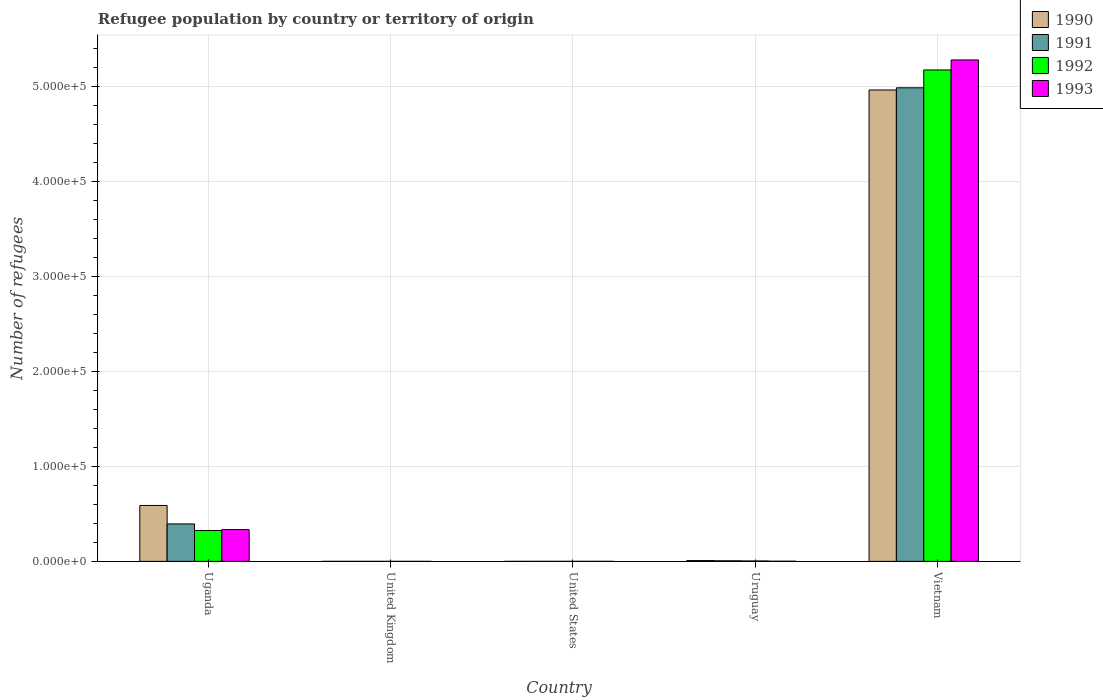How many groups of bars are there?
Your response must be concise. 5. Are the number of bars on each tick of the X-axis equal?
Your answer should be compact. Yes. How many bars are there on the 3rd tick from the left?
Provide a succinct answer. 4. What is the label of the 2nd group of bars from the left?
Offer a terse response. United Kingdom. In how many cases, is the number of bars for a given country not equal to the number of legend labels?
Your response must be concise. 0. Across all countries, what is the maximum number of refugees in 1991?
Make the answer very short. 4.98e+05. In which country was the number of refugees in 1991 maximum?
Your answer should be very brief. Vietnam. In which country was the number of refugees in 1991 minimum?
Your answer should be very brief. United Kingdom. What is the total number of refugees in 1990 in the graph?
Your answer should be compact. 5.56e+05. What is the average number of refugees in 1991 per country?
Make the answer very short. 1.08e+05. What is the difference between the number of refugees of/in 1993 and number of refugees of/in 1991 in Vietnam?
Your answer should be very brief. 2.93e+04. In how many countries, is the number of refugees in 1991 greater than 440000?
Provide a short and direct response. 1. What is the ratio of the number of refugees in 1990 in United States to that in Vietnam?
Provide a short and direct response. 2.0160111606377854e-6. Is the difference between the number of refugees in 1993 in United Kingdom and United States greater than the difference between the number of refugees in 1991 in United Kingdom and United States?
Provide a short and direct response. No. What is the difference between the highest and the second highest number of refugees in 1991?
Keep it short and to the point. -3.88e+04. What is the difference between the highest and the lowest number of refugees in 1992?
Your answer should be very brief. 5.17e+05. In how many countries, is the number of refugees in 1992 greater than the average number of refugees in 1992 taken over all countries?
Offer a very short reply. 1. Is it the case that in every country, the sum of the number of refugees in 1990 and number of refugees in 1992 is greater than the sum of number of refugees in 1993 and number of refugees in 1991?
Provide a short and direct response. No. What does the 1st bar from the left in Uruguay represents?
Provide a short and direct response. 1990. How many bars are there?
Provide a short and direct response. 20. Are all the bars in the graph horizontal?
Give a very brief answer. No. Are the values on the major ticks of Y-axis written in scientific E-notation?
Your answer should be very brief. Yes. Does the graph contain any zero values?
Offer a terse response. No. Does the graph contain grids?
Make the answer very short. Yes. How many legend labels are there?
Your answer should be compact. 4. How are the legend labels stacked?
Offer a very short reply. Vertical. What is the title of the graph?
Your answer should be compact. Refugee population by country or territory of origin. Does "1990" appear as one of the legend labels in the graph?
Your answer should be very brief. Yes. What is the label or title of the X-axis?
Your answer should be compact. Country. What is the label or title of the Y-axis?
Make the answer very short. Number of refugees. What is the Number of refugees of 1990 in Uganda?
Keep it short and to the point. 5.88e+04. What is the Number of refugees of 1991 in Uganda?
Offer a terse response. 3.94e+04. What is the Number of refugees of 1992 in Uganda?
Offer a very short reply. 3.25e+04. What is the Number of refugees in 1993 in Uganda?
Offer a terse response. 3.34e+04. What is the Number of refugees of 1990 in United States?
Make the answer very short. 1. What is the Number of refugees in 1991 in United States?
Provide a succinct answer. 8. What is the Number of refugees of 1992 in United States?
Offer a very short reply. 10. What is the Number of refugees of 1990 in Uruguay?
Offer a terse response. 842. What is the Number of refugees in 1991 in Uruguay?
Give a very brief answer. 601. What is the Number of refugees of 1992 in Uruguay?
Provide a succinct answer. 429. What is the Number of refugees of 1993 in Uruguay?
Provide a short and direct response. 162. What is the Number of refugees of 1990 in Vietnam?
Offer a terse response. 4.96e+05. What is the Number of refugees in 1991 in Vietnam?
Offer a terse response. 4.98e+05. What is the Number of refugees in 1992 in Vietnam?
Offer a very short reply. 5.17e+05. What is the Number of refugees of 1993 in Vietnam?
Your answer should be compact. 5.28e+05. Across all countries, what is the maximum Number of refugees in 1990?
Give a very brief answer. 4.96e+05. Across all countries, what is the maximum Number of refugees in 1991?
Your answer should be compact. 4.98e+05. Across all countries, what is the maximum Number of refugees of 1992?
Offer a very short reply. 5.17e+05. Across all countries, what is the maximum Number of refugees of 1993?
Your answer should be compact. 5.28e+05. Across all countries, what is the minimum Number of refugees of 1990?
Your response must be concise. 1. Across all countries, what is the minimum Number of refugees of 1991?
Keep it short and to the point. 1. What is the total Number of refugees of 1990 in the graph?
Your answer should be very brief. 5.56e+05. What is the total Number of refugees of 1991 in the graph?
Your response must be concise. 5.38e+05. What is the total Number of refugees of 1992 in the graph?
Your answer should be compact. 5.50e+05. What is the total Number of refugees of 1993 in the graph?
Offer a terse response. 5.61e+05. What is the difference between the Number of refugees of 1990 in Uganda and that in United Kingdom?
Offer a very short reply. 5.88e+04. What is the difference between the Number of refugees of 1991 in Uganda and that in United Kingdom?
Provide a succinct answer. 3.94e+04. What is the difference between the Number of refugees of 1992 in Uganda and that in United Kingdom?
Your response must be concise. 3.25e+04. What is the difference between the Number of refugees of 1993 in Uganda and that in United Kingdom?
Offer a terse response. 3.34e+04. What is the difference between the Number of refugees in 1990 in Uganda and that in United States?
Keep it short and to the point. 5.88e+04. What is the difference between the Number of refugees of 1991 in Uganda and that in United States?
Provide a succinct answer. 3.94e+04. What is the difference between the Number of refugees in 1992 in Uganda and that in United States?
Make the answer very short. 3.24e+04. What is the difference between the Number of refugees in 1993 in Uganda and that in United States?
Your answer should be very brief. 3.34e+04. What is the difference between the Number of refugees of 1990 in Uganda and that in Uruguay?
Provide a short and direct response. 5.80e+04. What is the difference between the Number of refugees of 1991 in Uganda and that in Uruguay?
Offer a terse response. 3.88e+04. What is the difference between the Number of refugees of 1992 in Uganda and that in Uruguay?
Give a very brief answer. 3.20e+04. What is the difference between the Number of refugees of 1993 in Uganda and that in Uruguay?
Offer a very short reply. 3.33e+04. What is the difference between the Number of refugees of 1990 in Uganda and that in Vietnam?
Provide a succinct answer. -4.37e+05. What is the difference between the Number of refugees of 1991 in Uganda and that in Vietnam?
Ensure brevity in your answer.  -4.59e+05. What is the difference between the Number of refugees in 1992 in Uganda and that in Vietnam?
Offer a terse response. -4.85e+05. What is the difference between the Number of refugees of 1993 in Uganda and that in Vietnam?
Keep it short and to the point. -4.94e+05. What is the difference between the Number of refugees in 1990 in United Kingdom and that in United States?
Provide a succinct answer. 0. What is the difference between the Number of refugees in 1991 in United Kingdom and that in United States?
Your answer should be very brief. -7. What is the difference between the Number of refugees in 1992 in United Kingdom and that in United States?
Ensure brevity in your answer.  -9. What is the difference between the Number of refugees in 1990 in United Kingdom and that in Uruguay?
Give a very brief answer. -841. What is the difference between the Number of refugees in 1991 in United Kingdom and that in Uruguay?
Make the answer very short. -600. What is the difference between the Number of refugees of 1992 in United Kingdom and that in Uruguay?
Keep it short and to the point. -428. What is the difference between the Number of refugees in 1993 in United Kingdom and that in Uruguay?
Give a very brief answer. -160. What is the difference between the Number of refugees in 1990 in United Kingdom and that in Vietnam?
Offer a terse response. -4.96e+05. What is the difference between the Number of refugees in 1991 in United Kingdom and that in Vietnam?
Provide a short and direct response. -4.98e+05. What is the difference between the Number of refugees of 1992 in United Kingdom and that in Vietnam?
Provide a short and direct response. -5.17e+05. What is the difference between the Number of refugees in 1993 in United Kingdom and that in Vietnam?
Your answer should be very brief. -5.28e+05. What is the difference between the Number of refugees of 1990 in United States and that in Uruguay?
Your answer should be compact. -841. What is the difference between the Number of refugees of 1991 in United States and that in Uruguay?
Give a very brief answer. -593. What is the difference between the Number of refugees in 1992 in United States and that in Uruguay?
Keep it short and to the point. -419. What is the difference between the Number of refugees in 1993 in United States and that in Uruguay?
Keep it short and to the point. -150. What is the difference between the Number of refugees of 1990 in United States and that in Vietnam?
Provide a short and direct response. -4.96e+05. What is the difference between the Number of refugees in 1991 in United States and that in Vietnam?
Offer a very short reply. -4.98e+05. What is the difference between the Number of refugees of 1992 in United States and that in Vietnam?
Ensure brevity in your answer.  -5.17e+05. What is the difference between the Number of refugees in 1993 in United States and that in Vietnam?
Keep it short and to the point. -5.28e+05. What is the difference between the Number of refugees in 1990 in Uruguay and that in Vietnam?
Ensure brevity in your answer.  -4.95e+05. What is the difference between the Number of refugees of 1991 in Uruguay and that in Vietnam?
Give a very brief answer. -4.98e+05. What is the difference between the Number of refugees of 1992 in Uruguay and that in Vietnam?
Provide a succinct answer. -5.17e+05. What is the difference between the Number of refugees in 1993 in Uruguay and that in Vietnam?
Give a very brief answer. -5.27e+05. What is the difference between the Number of refugees in 1990 in Uganda and the Number of refugees in 1991 in United Kingdom?
Your response must be concise. 5.88e+04. What is the difference between the Number of refugees in 1990 in Uganda and the Number of refugees in 1992 in United Kingdom?
Give a very brief answer. 5.88e+04. What is the difference between the Number of refugees of 1990 in Uganda and the Number of refugees of 1993 in United Kingdom?
Offer a very short reply. 5.88e+04. What is the difference between the Number of refugees of 1991 in Uganda and the Number of refugees of 1992 in United Kingdom?
Keep it short and to the point. 3.94e+04. What is the difference between the Number of refugees in 1991 in Uganda and the Number of refugees in 1993 in United Kingdom?
Provide a short and direct response. 3.94e+04. What is the difference between the Number of refugees of 1992 in Uganda and the Number of refugees of 1993 in United Kingdom?
Provide a short and direct response. 3.25e+04. What is the difference between the Number of refugees of 1990 in Uganda and the Number of refugees of 1991 in United States?
Your answer should be compact. 5.88e+04. What is the difference between the Number of refugees in 1990 in Uganda and the Number of refugees in 1992 in United States?
Give a very brief answer. 5.88e+04. What is the difference between the Number of refugees in 1990 in Uganda and the Number of refugees in 1993 in United States?
Give a very brief answer. 5.88e+04. What is the difference between the Number of refugees of 1991 in Uganda and the Number of refugees of 1992 in United States?
Offer a terse response. 3.94e+04. What is the difference between the Number of refugees in 1991 in Uganda and the Number of refugees in 1993 in United States?
Provide a short and direct response. 3.94e+04. What is the difference between the Number of refugees of 1992 in Uganda and the Number of refugees of 1993 in United States?
Make the answer very short. 3.24e+04. What is the difference between the Number of refugees of 1990 in Uganda and the Number of refugees of 1991 in Uruguay?
Provide a short and direct response. 5.82e+04. What is the difference between the Number of refugees of 1990 in Uganda and the Number of refugees of 1992 in Uruguay?
Give a very brief answer. 5.84e+04. What is the difference between the Number of refugees in 1990 in Uganda and the Number of refugees in 1993 in Uruguay?
Your answer should be compact. 5.87e+04. What is the difference between the Number of refugees in 1991 in Uganda and the Number of refugees in 1992 in Uruguay?
Offer a terse response. 3.90e+04. What is the difference between the Number of refugees of 1991 in Uganda and the Number of refugees of 1993 in Uruguay?
Offer a terse response. 3.92e+04. What is the difference between the Number of refugees in 1992 in Uganda and the Number of refugees in 1993 in Uruguay?
Make the answer very short. 3.23e+04. What is the difference between the Number of refugees of 1990 in Uganda and the Number of refugees of 1991 in Vietnam?
Ensure brevity in your answer.  -4.40e+05. What is the difference between the Number of refugees of 1990 in Uganda and the Number of refugees of 1992 in Vietnam?
Ensure brevity in your answer.  -4.58e+05. What is the difference between the Number of refugees in 1990 in Uganda and the Number of refugees in 1993 in Vietnam?
Keep it short and to the point. -4.69e+05. What is the difference between the Number of refugees of 1991 in Uganda and the Number of refugees of 1992 in Vietnam?
Your answer should be compact. -4.78e+05. What is the difference between the Number of refugees of 1991 in Uganda and the Number of refugees of 1993 in Vietnam?
Keep it short and to the point. -4.88e+05. What is the difference between the Number of refugees of 1992 in Uganda and the Number of refugees of 1993 in Vietnam?
Provide a succinct answer. -4.95e+05. What is the difference between the Number of refugees of 1990 in United Kingdom and the Number of refugees of 1992 in United States?
Your answer should be compact. -9. What is the difference between the Number of refugees in 1990 in United Kingdom and the Number of refugees in 1993 in United States?
Your answer should be compact. -11. What is the difference between the Number of refugees of 1991 in United Kingdom and the Number of refugees of 1993 in United States?
Keep it short and to the point. -11. What is the difference between the Number of refugees in 1990 in United Kingdom and the Number of refugees in 1991 in Uruguay?
Offer a terse response. -600. What is the difference between the Number of refugees in 1990 in United Kingdom and the Number of refugees in 1992 in Uruguay?
Provide a short and direct response. -428. What is the difference between the Number of refugees of 1990 in United Kingdom and the Number of refugees of 1993 in Uruguay?
Give a very brief answer. -161. What is the difference between the Number of refugees in 1991 in United Kingdom and the Number of refugees in 1992 in Uruguay?
Ensure brevity in your answer.  -428. What is the difference between the Number of refugees of 1991 in United Kingdom and the Number of refugees of 1993 in Uruguay?
Offer a very short reply. -161. What is the difference between the Number of refugees in 1992 in United Kingdom and the Number of refugees in 1993 in Uruguay?
Keep it short and to the point. -161. What is the difference between the Number of refugees in 1990 in United Kingdom and the Number of refugees in 1991 in Vietnam?
Make the answer very short. -4.98e+05. What is the difference between the Number of refugees of 1990 in United Kingdom and the Number of refugees of 1992 in Vietnam?
Keep it short and to the point. -5.17e+05. What is the difference between the Number of refugees of 1990 in United Kingdom and the Number of refugees of 1993 in Vietnam?
Your answer should be compact. -5.28e+05. What is the difference between the Number of refugees of 1991 in United Kingdom and the Number of refugees of 1992 in Vietnam?
Make the answer very short. -5.17e+05. What is the difference between the Number of refugees of 1991 in United Kingdom and the Number of refugees of 1993 in Vietnam?
Make the answer very short. -5.28e+05. What is the difference between the Number of refugees in 1992 in United Kingdom and the Number of refugees in 1993 in Vietnam?
Offer a terse response. -5.28e+05. What is the difference between the Number of refugees of 1990 in United States and the Number of refugees of 1991 in Uruguay?
Your answer should be compact. -600. What is the difference between the Number of refugees of 1990 in United States and the Number of refugees of 1992 in Uruguay?
Give a very brief answer. -428. What is the difference between the Number of refugees in 1990 in United States and the Number of refugees in 1993 in Uruguay?
Make the answer very short. -161. What is the difference between the Number of refugees in 1991 in United States and the Number of refugees in 1992 in Uruguay?
Provide a succinct answer. -421. What is the difference between the Number of refugees in 1991 in United States and the Number of refugees in 1993 in Uruguay?
Ensure brevity in your answer.  -154. What is the difference between the Number of refugees in 1992 in United States and the Number of refugees in 1993 in Uruguay?
Ensure brevity in your answer.  -152. What is the difference between the Number of refugees of 1990 in United States and the Number of refugees of 1991 in Vietnam?
Ensure brevity in your answer.  -4.98e+05. What is the difference between the Number of refugees in 1990 in United States and the Number of refugees in 1992 in Vietnam?
Provide a succinct answer. -5.17e+05. What is the difference between the Number of refugees of 1990 in United States and the Number of refugees of 1993 in Vietnam?
Provide a succinct answer. -5.28e+05. What is the difference between the Number of refugees of 1991 in United States and the Number of refugees of 1992 in Vietnam?
Make the answer very short. -5.17e+05. What is the difference between the Number of refugees in 1991 in United States and the Number of refugees in 1993 in Vietnam?
Your answer should be very brief. -5.28e+05. What is the difference between the Number of refugees in 1992 in United States and the Number of refugees in 1993 in Vietnam?
Offer a very short reply. -5.28e+05. What is the difference between the Number of refugees in 1990 in Uruguay and the Number of refugees in 1991 in Vietnam?
Provide a short and direct response. -4.97e+05. What is the difference between the Number of refugees of 1990 in Uruguay and the Number of refugees of 1992 in Vietnam?
Your response must be concise. -5.16e+05. What is the difference between the Number of refugees in 1990 in Uruguay and the Number of refugees in 1993 in Vietnam?
Offer a very short reply. -5.27e+05. What is the difference between the Number of refugees of 1991 in Uruguay and the Number of refugees of 1992 in Vietnam?
Provide a succinct answer. -5.17e+05. What is the difference between the Number of refugees of 1991 in Uruguay and the Number of refugees of 1993 in Vietnam?
Provide a short and direct response. -5.27e+05. What is the difference between the Number of refugees in 1992 in Uruguay and the Number of refugees in 1993 in Vietnam?
Ensure brevity in your answer.  -5.27e+05. What is the average Number of refugees in 1990 per country?
Your response must be concise. 1.11e+05. What is the average Number of refugees in 1991 per country?
Provide a short and direct response. 1.08e+05. What is the average Number of refugees of 1992 per country?
Provide a short and direct response. 1.10e+05. What is the average Number of refugees of 1993 per country?
Give a very brief answer. 1.12e+05. What is the difference between the Number of refugees in 1990 and Number of refugees in 1991 in Uganda?
Your answer should be compact. 1.94e+04. What is the difference between the Number of refugees in 1990 and Number of refugees in 1992 in Uganda?
Make the answer very short. 2.64e+04. What is the difference between the Number of refugees in 1990 and Number of refugees in 1993 in Uganda?
Provide a short and direct response. 2.54e+04. What is the difference between the Number of refugees in 1991 and Number of refugees in 1992 in Uganda?
Your response must be concise. 6930. What is the difference between the Number of refugees of 1991 and Number of refugees of 1993 in Uganda?
Ensure brevity in your answer.  5971. What is the difference between the Number of refugees of 1992 and Number of refugees of 1993 in Uganda?
Give a very brief answer. -959. What is the difference between the Number of refugees in 1990 and Number of refugees in 1991 in United Kingdom?
Ensure brevity in your answer.  0. What is the difference between the Number of refugees of 1990 and Number of refugees of 1992 in United Kingdom?
Ensure brevity in your answer.  0. What is the difference between the Number of refugees of 1990 and Number of refugees of 1993 in United Kingdom?
Your answer should be compact. -1. What is the difference between the Number of refugees of 1991 and Number of refugees of 1992 in United Kingdom?
Give a very brief answer. 0. What is the difference between the Number of refugees in 1991 and Number of refugees in 1993 in United Kingdom?
Give a very brief answer. -1. What is the difference between the Number of refugees in 1990 and Number of refugees in 1991 in United States?
Keep it short and to the point. -7. What is the difference between the Number of refugees of 1991 and Number of refugees of 1992 in United States?
Provide a short and direct response. -2. What is the difference between the Number of refugees in 1992 and Number of refugees in 1993 in United States?
Provide a short and direct response. -2. What is the difference between the Number of refugees of 1990 and Number of refugees of 1991 in Uruguay?
Provide a short and direct response. 241. What is the difference between the Number of refugees in 1990 and Number of refugees in 1992 in Uruguay?
Offer a terse response. 413. What is the difference between the Number of refugees in 1990 and Number of refugees in 1993 in Uruguay?
Provide a succinct answer. 680. What is the difference between the Number of refugees in 1991 and Number of refugees in 1992 in Uruguay?
Your response must be concise. 172. What is the difference between the Number of refugees of 1991 and Number of refugees of 1993 in Uruguay?
Your answer should be compact. 439. What is the difference between the Number of refugees in 1992 and Number of refugees in 1993 in Uruguay?
Offer a terse response. 267. What is the difference between the Number of refugees of 1990 and Number of refugees of 1991 in Vietnam?
Give a very brief answer. -2294. What is the difference between the Number of refugees in 1990 and Number of refugees in 1992 in Vietnam?
Your response must be concise. -2.11e+04. What is the difference between the Number of refugees in 1990 and Number of refugees in 1993 in Vietnam?
Provide a succinct answer. -3.16e+04. What is the difference between the Number of refugees in 1991 and Number of refugees in 1992 in Vietnam?
Offer a very short reply. -1.88e+04. What is the difference between the Number of refugees of 1991 and Number of refugees of 1993 in Vietnam?
Keep it short and to the point. -2.93e+04. What is the difference between the Number of refugees of 1992 and Number of refugees of 1993 in Vietnam?
Offer a very short reply. -1.05e+04. What is the ratio of the Number of refugees of 1990 in Uganda to that in United Kingdom?
Your answer should be compact. 5.88e+04. What is the ratio of the Number of refugees in 1991 in Uganda to that in United Kingdom?
Offer a very short reply. 3.94e+04. What is the ratio of the Number of refugees of 1992 in Uganda to that in United Kingdom?
Your response must be concise. 3.25e+04. What is the ratio of the Number of refugees of 1993 in Uganda to that in United Kingdom?
Ensure brevity in your answer.  1.67e+04. What is the ratio of the Number of refugees in 1990 in Uganda to that in United States?
Your answer should be compact. 5.88e+04. What is the ratio of the Number of refugees in 1991 in Uganda to that in United States?
Provide a succinct answer. 4923.25. What is the ratio of the Number of refugees of 1992 in Uganda to that in United States?
Offer a terse response. 3245.6. What is the ratio of the Number of refugees in 1993 in Uganda to that in United States?
Provide a short and direct response. 2784.58. What is the ratio of the Number of refugees of 1990 in Uganda to that in Uruguay?
Keep it short and to the point. 69.86. What is the ratio of the Number of refugees of 1991 in Uganda to that in Uruguay?
Your answer should be very brief. 65.53. What is the ratio of the Number of refugees in 1992 in Uganda to that in Uruguay?
Keep it short and to the point. 75.66. What is the ratio of the Number of refugees in 1993 in Uganda to that in Uruguay?
Make the answer very short. 206.27. What is the ratio of the Number of refugees of 1990 in Uganda to that in Vietnam?
Your response must be concise. 0.12. What is the ratio of the Number of refugees in 1991 in Uganda to that in Vietnam?
Provide a succinct answer. 0.08. What is the ratio of the Number of refugees in 1992 in Uganda to that in Vietnam?
Keep it short and to the point. 0.06. What is the ratio of the Number of refugees of 1993 in Uganda to that in Vietnam?
Your response must be concise. 0.06. What is the ratio of the Number of refugees of 1992 in United Kingdom to that in United States?
Give a very brief answer. 0.1. What is the ratio of the Number of refugees in 1990 in United Kingdom to that in Uruguay?
Provide a succinct answer. 0. What is the ratio of the Number of refugees of 1991 in United Kingdom to that in Uruguay?
Provide a short and direct response. 0. What is the ratio of the Number of refugees in 1992 in United Kingdom to that in Uruguay?
Ensure brevity in your answer.  0. What is the ratio of the Number of refugees in 1993 in United Kingdom to that in Uruguay?
Provide a succinct answer. 0.01. What is the ratio of the Number of refugees of 1991 in United Kingdom to that in Vietnam?
Provide a succinct answer. 0. What is the ratio of the Number of refugees of 1993 in United Kingdom to that in Vietnam?
Offer a terse response. 0. What is the ratio of the Number of refugees of 1990 in United States to that in Uruguay?
Provide a succinct answer. 0. What is the ratio of the Number of refugees in 1991 in United States to that in Uruguay?
Give a very brief answer. 0.01. What is the ratio of the Number of refugees in 1992 in United States to that in Uruguay?
Provide a succinct answer. 0.02. What is the ratio of the Number of refugees in 1993 in United States to that in Uruguay?
Provide a succinct answer. 0.07. What is the ratio of the Number of refugees in 1990 in United States to that in Vietnam?
Keep it short and to the point. 0. What is the ratio of the Number of refugees in 1991 in United States to that in Vietnam?
Offer a terse response. 0. What is the ratio of the Number of refugees of 1992 in United States to that in Vietnam?
Your answer should be very brief. 0. What is the ratio of the Number of refugees in 1993 in United States to that in Vietnam?
Provide a succinct answer. 0. What is the ratio of the Number of refugees of 1990 in Uruguay to that in Vietnam?
Your response must be concise. 0. What is the ratio of the Number of refugees of 1991 in Uruguay to that in Vietnam?
Ensure brevity in your answer.  0. What is the ratio of the Number of refugees in 1992 in Uruguay to that in Vietnam?
Ensure brevity in your answer.  0. What is the ratio of the Number of refugees of 1993 in Uruguay to that in Vietnam?
Your answer should be very brief. 0. What is the difference between the highest and the second highest Number of refugees of 1990?
Keep it short and to the point. 4.37e+05. What is the difference between the highest and the second highest Number of refugees of 1991?
Your response must be concise. 4.59e+05. What is the difference between the highest and the second highest Number of refugees in 1992?
Ensure brevity in your answer.  4.85e+05. What is the difference between the highest and the second highest Number of refugees in 1993?
Give a very brief answer. 4.94e+05. What is the difference between the highest and the lowest Number of refugees of 1990?
Ensure brevity in your answer.  4.96e+05. What is the difference between the highest and the lowest Number of refugees in 1991?
Provide a succinct answer. 4.98e+05. What is the difference between the highest and the lowest Number of refugees in 1992?
Provide a short and direct response. 5.17e+05. What is the difference between the highest and the lowest Number of refugees of 1993?
Give a very brief answer. 5.28e+05. 